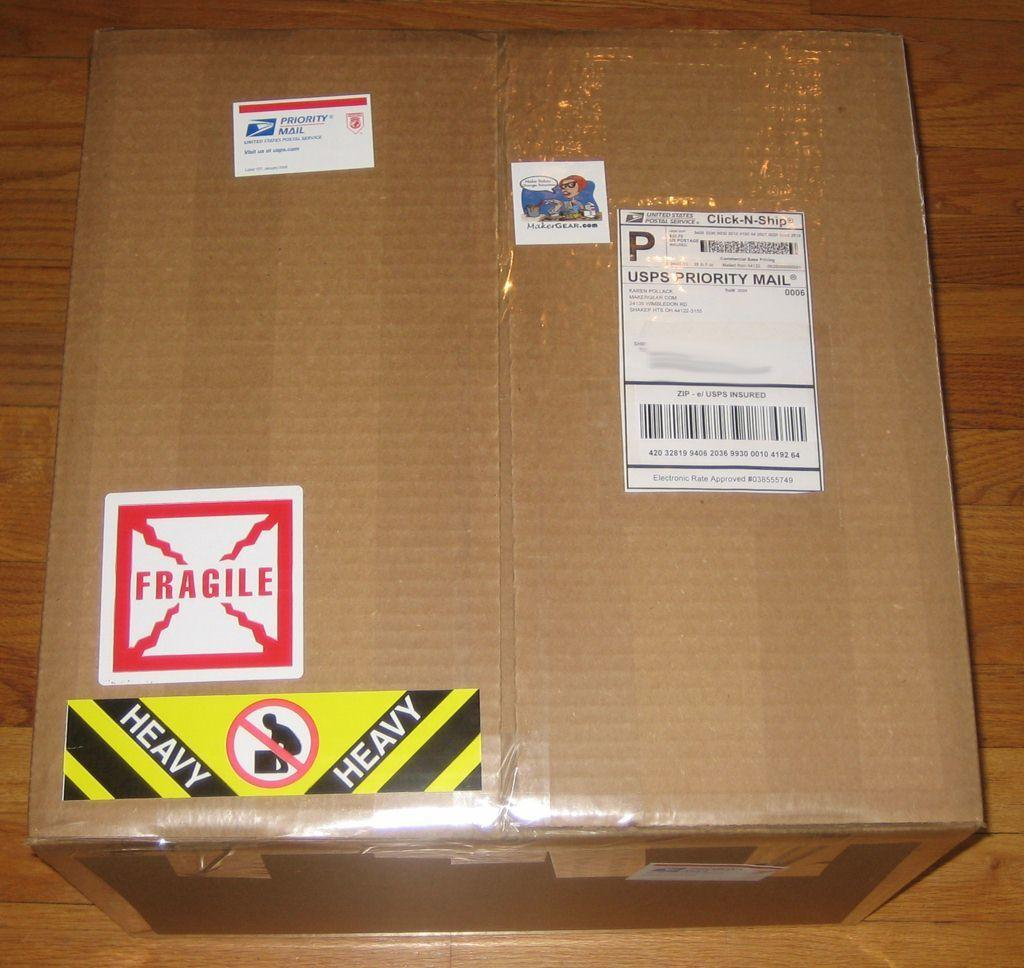<image>
Write a terse but informative summary of the picture. A box with a fragile sticker and a heavy sticker on it. 